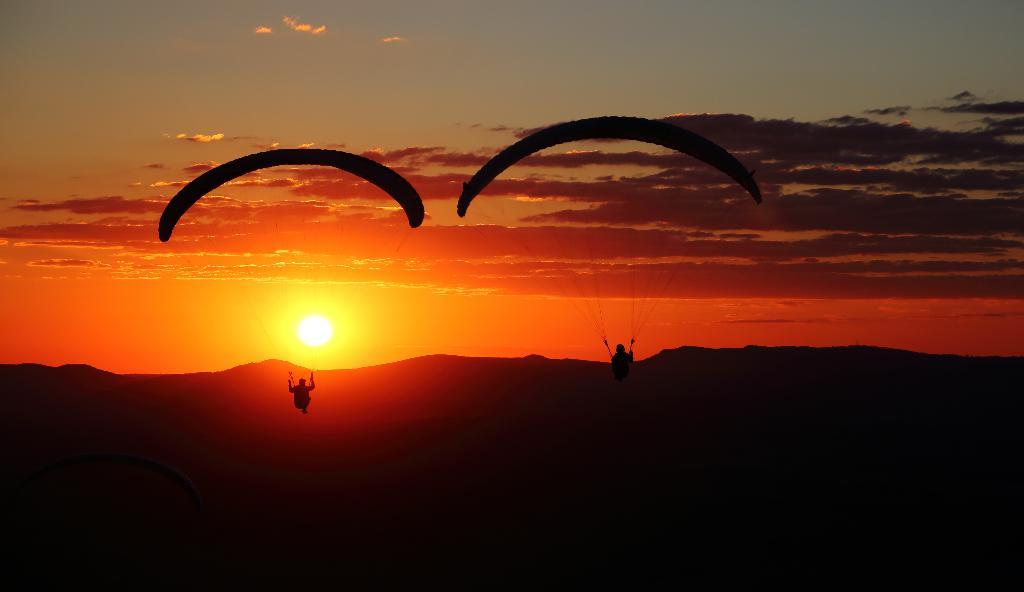How many people are in the image? There are two people in the image. What are the people wearing in the image? The people are wearing parachutes in the image. Where are the people located in the image? The people are in the air in the image. What can be seen in the background of the image? Mountains, the sun, clouds, and the sky are visible in the background of the image. What type of quince can be seen growing on the mountains in the image? There is no quince visible in the image, and the mountains do not have any plants growing on them. What type of music can be heard playing in the background of the image? There is no music present in the image, as it is a visual representation without any sound. 